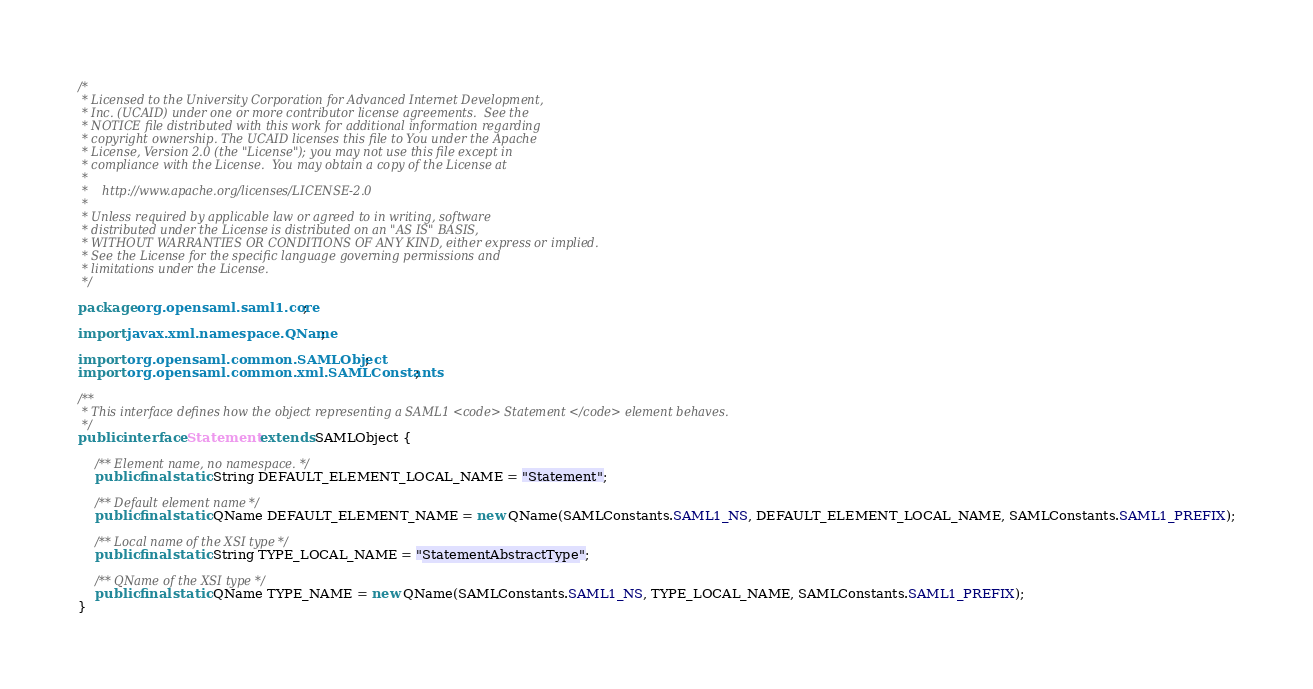Convert code to text. <code><loc_0><loc_0><loc_500><loc_500><_Java_>/*
 * Licensed to the University Corporation for Advanced Internet Development, 
 * Inc. (UCAID) under one or more contributor license agreements.  See the 
 * NOTICE file distributed with this work for additional information regarding
 * copyright ownership. The UCAID licenses this file to You under the Apache 
 * License, Version 2.0 (the "License"); you may not use this file except in 
 * compliance with the License.  You may obtain a copy of the License at
 *
 *    http://www.apache.org/licenses/LICENSE-2.0
 *
 * Unless required by applicable law or agreed to in writing, software
 * distributed under the License is distributed on an "AS IS" BASIS,
 * WITHOUT WARRANTIES OR CONDITIONS OF ANY KIND, either express or implied.
 * See the License for the specific language governing permissions and
 * limitations under the License.
 */

package org.opensaml.saml1.core;

import javax.xml.namespace.QName;

import org.opensaml.common.SAMLObject;
import org.opensaml.common.xml.SAMLConstants;

/**
 * This interface defines how the object representing a SAML1 <code> Statement </code> element behaves. 
 */
public interface Statement extends SAMLObject {

    /** Element name, no namespace. */
    public final static String DEFAULT_ELEMENT_LOCAL_NAME = "Statement";
    
    /** Default element name */
    public final static QName DEFAULT_ELEMENT_NAME = new QName(SAMLConstants.SAML1_NS, DEFAULT_ELEMENT_LOCAL_NAME, SAMLConstants.SAML1_PREFIX);
    
    /** Local name of the XSI type */
    public final static String TYPE_LOCAL_NAME = "StatementAbstractType"; 
        
    /** QName of the XSI type */
    public final static QName TYPE_NAME = new QName(SAMLConstants.SAML1_NS, TYPE_LOCAL_NAME, SAMLConstants.SAML1_PREFIX);
}</code> 